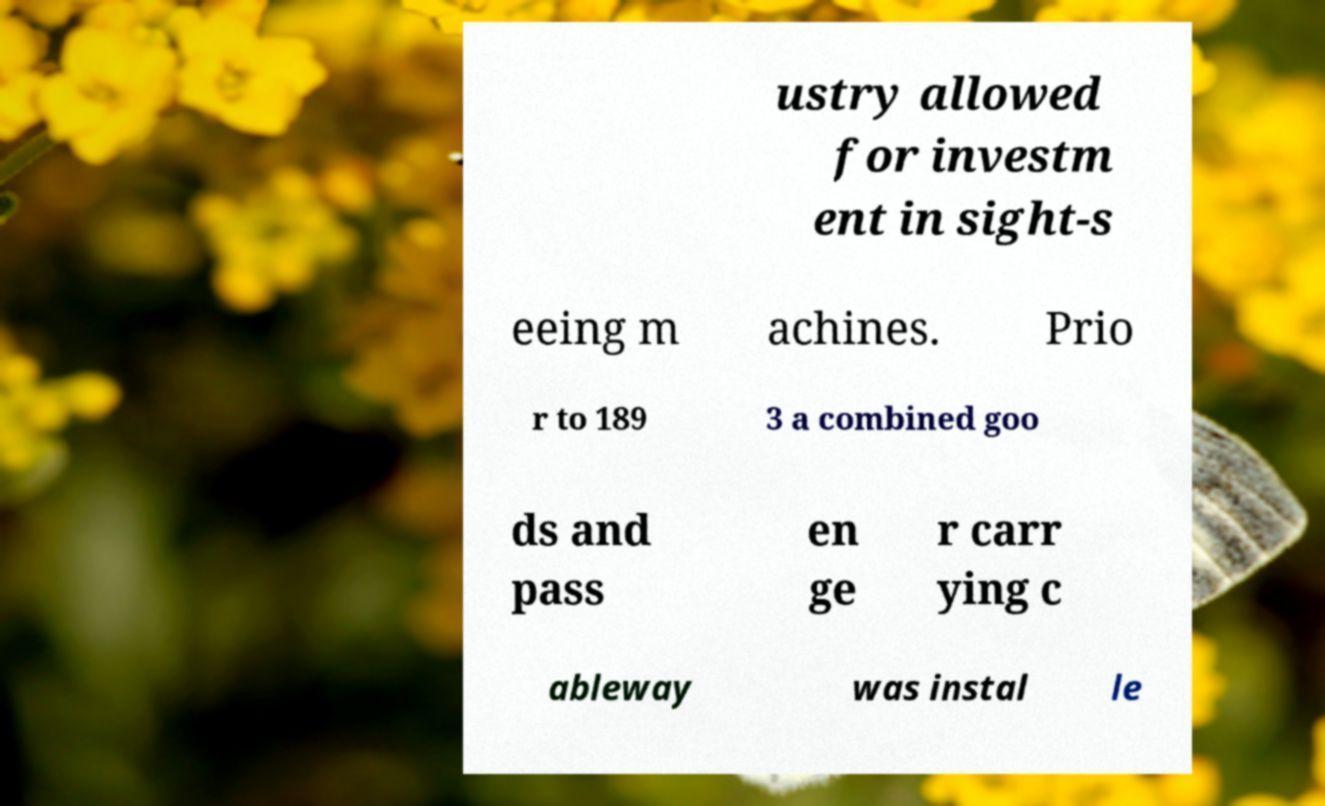Can you read and provide the text displayed in the image?This photo seems to have some interesting text. Can you extract and type it out for me? ustry allowed for investm ent in sight-s eeing m achines. Prio r to 189 3 a combined goo ds and pass en ge r carr ying c ableway was instal le 